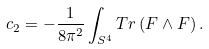Convert formula to latex. <formula><loc_0><loc_0><loc_500><loc_500>c _ { 2 } = - \frac { 1 } { 8 \pi ^ { 2 } } \int _ { S ^ { 4 } } T r \left ( F \wedge F \right ) .</formula> 